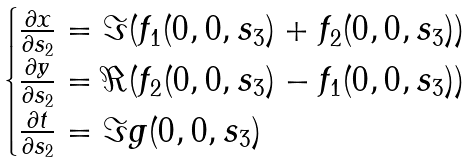Convert formula to latex. <formula><loc_0><loc_0><loc_500><loc_500>\begin{cases} \frac { \partial x } { \partial s _ { 2 } } = \Im ( f _ { 1 } ( 0 , 0 , s _ { 3 } ) + f _ { 2 } ( 0 , 0 , s _ { 3 } ) ) \\ \frac { \partial y } { \partial s _ { 2 } } = \Re ( f _ { 2 } ( 0 , 0 , s _ { 3 } ) - f _ { 1 } ( 0 , 0 , s _ { 3 } ) ) \\ \frac { \partial t } { \partial s _ { 2 } } = \Im g ( 0 , 0 , s _ { 3 } ) \end{cases}</formula> 